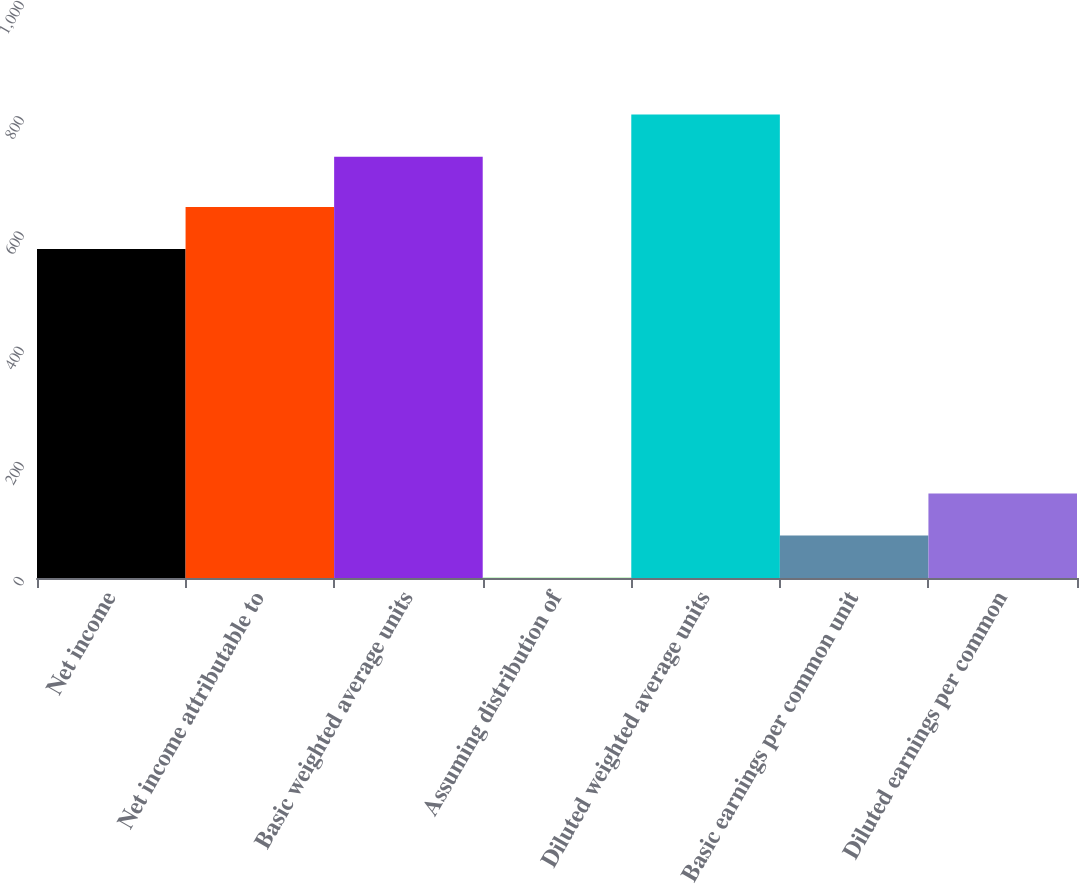Convert chart to OTSL. <chart><loc_0><loc_0><loc_500><loc_500><bar_chart><fcel>Net income<fcel>Net income attributable to<fcel>Basic weighted average units<fcel>Assuming distribution of<fcel>Diluted weighted average units<fcel>Basic earnings per common unit<fcel>Diluted earnings per common<nl><fcel>571<fcel>644.15<fcel>731.5<fcel>0.5<fcel>804.65<fcel>73.65<fcel>146.8<nl></chart> 